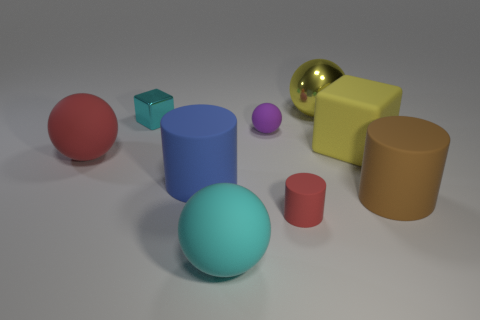How many other objects are there of the same shape as the big metal object?
Provide a short and direct response. 3. There is a cyan thing that is in front of the large brown cylinder; does it have the same shape as the brown object?
Your answer should be compact. No. Are there any big cylinders behind the tiny purple rubber thing?
Your response must be concise. No. How many large objects are either gray balls or blue matte cylinders?
Provide a short and direct response. 1. Does the big cyan ball have the same material as the brown cylinder?
Offer a terse response. Yes. The ball that is the same color as the small cylinder is what size?
Your answer should be very brief. Large. Is there a small rubber cylinder that has the same color as the tiny metal object?
Your response must be concise. No. What is the size of the yellow cube that is made of the same material as the small ball?
Your answer should be very brief. Large. What shape is the cyan thing that is right of the metal object that is left of the red object that is on the right side of the small purple matte thing?
Keep it short and to the point. Sphere. There is a cyan matte thing that is the same shape as the tiny purple matte object; what size is it?
Give a very brief answer. Large. 